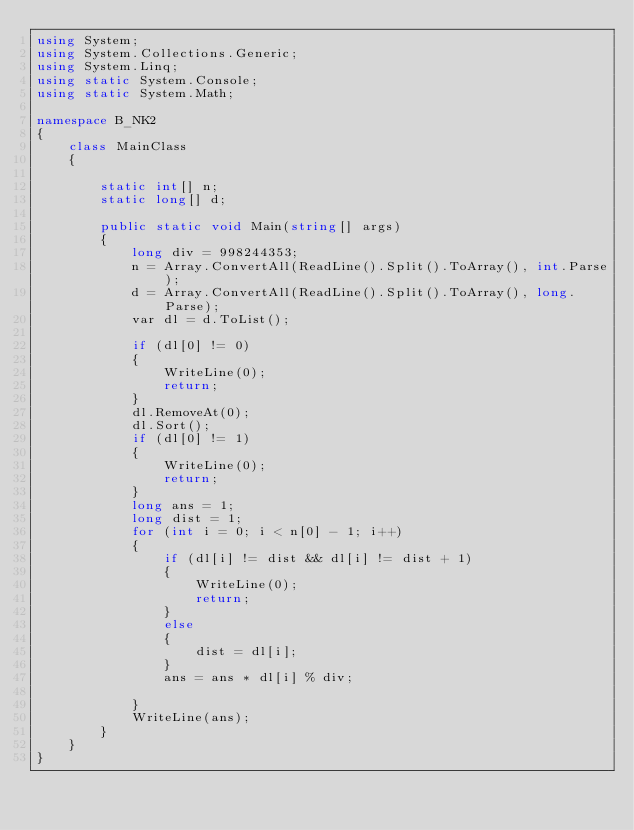Convert code to text. <code><loc_0><loc_0><loc_500><loc_500><_C#_>using System;
using System.Collections.Generic;
using System.Linq;
using static System.Console;
using static System.Math;

namespace B_NK2
{
    class MainClass
    {

        static int[] n;
        static long[] d;

        public static void Main(string[] args)
        {
            long div = 998244353;
            n = Array.ConvertAll(ReadLine().Split().ToArray(), int.Parse);
            d = Array.ConvertAll(ReadLine().Split().ToArray(), long.Parse);
            var dl = d.ToList();

            if (dl[0] != 0)
            {
                WriteLine(0);
                return;
            }
            dl.RemoveAt(0);
            dl.Sort();
            if (dl[0] != 1)
            {
                WriteLine(0);
                return;
            }
            long ans = 1;
            long dist = 1;
            for (int i = 0; i < n[0] - 1; i++)
            {
                if (dl[i] != dist && dl[i] != dist + 1)
                {
                    WriteLine(0);
                    return;
                }
                else
                {
                    dist = dl[i];
                }
                ans = ans * dl[i] % div;

            }
            WriteLine(ans);
        }
    }
}
</code> 